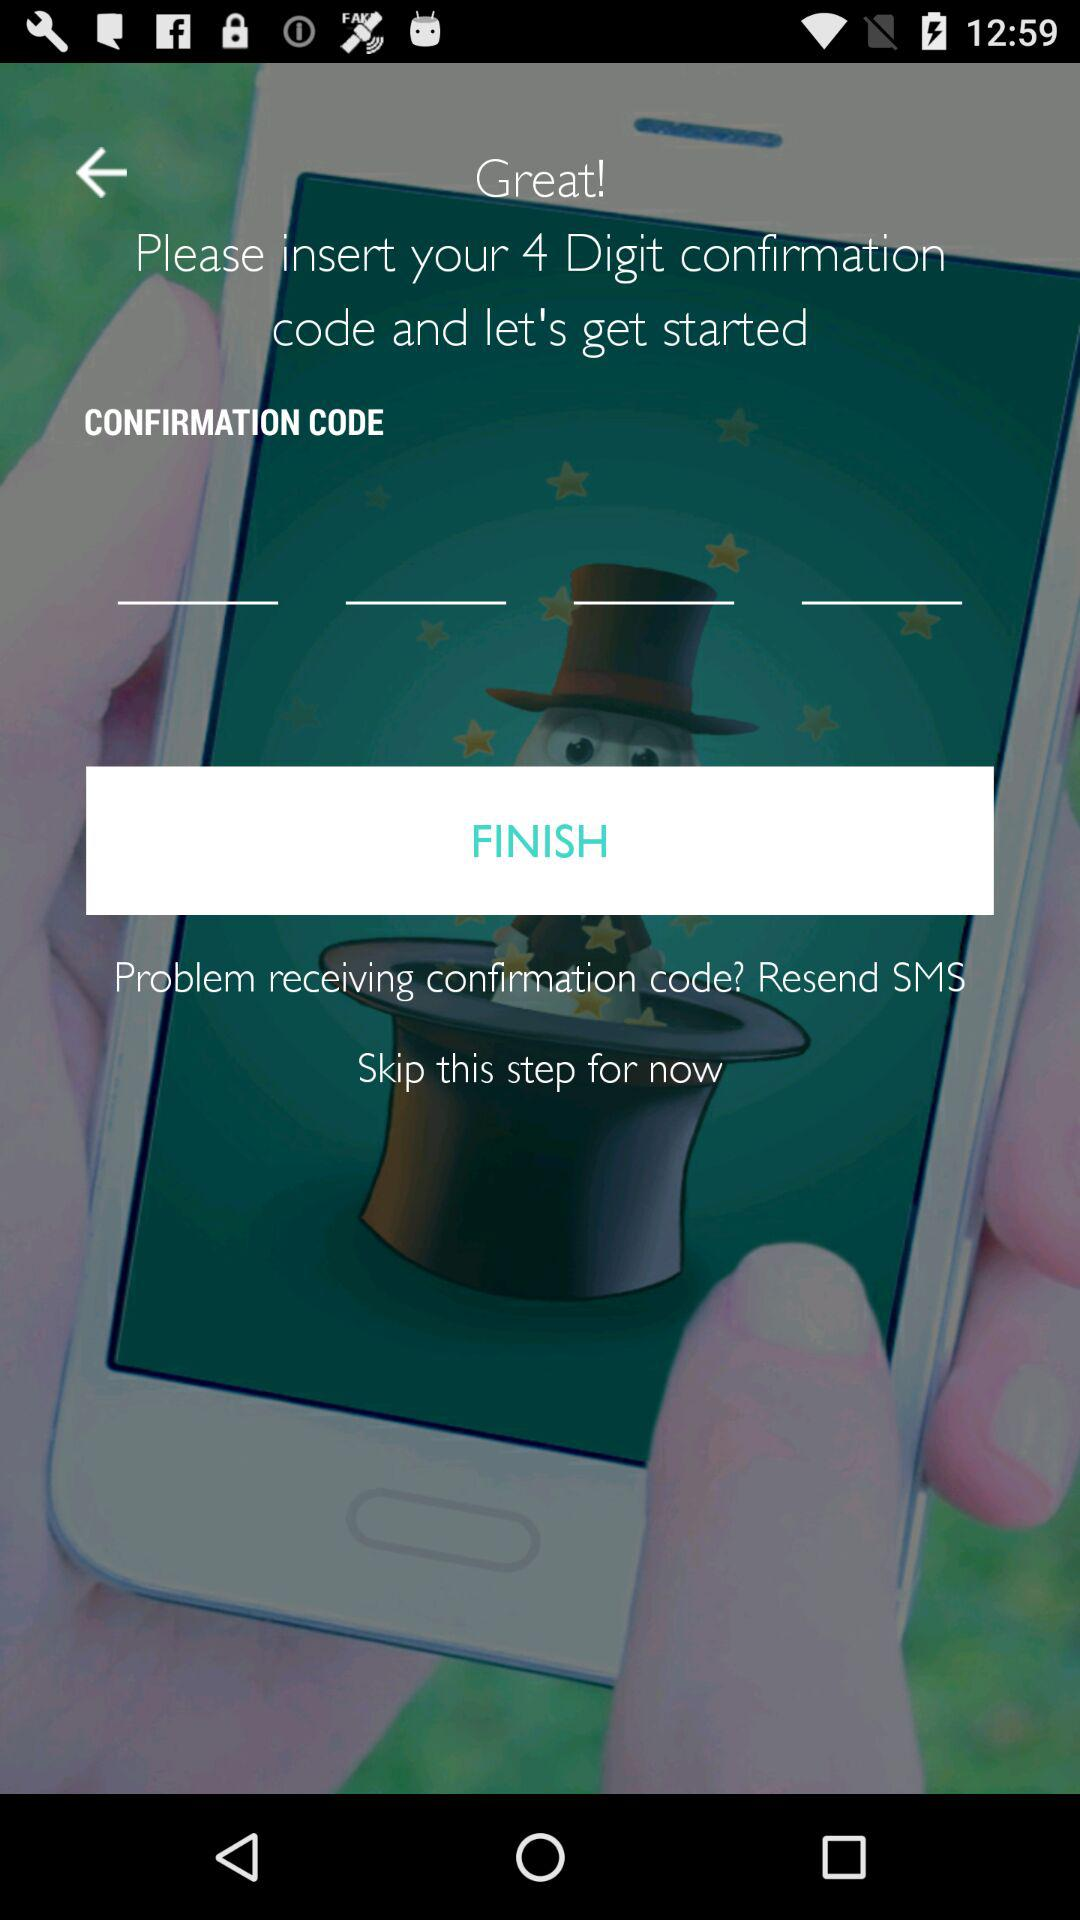How many digits are there in the confirmation code? There are 4 digits in the confirmation code. 